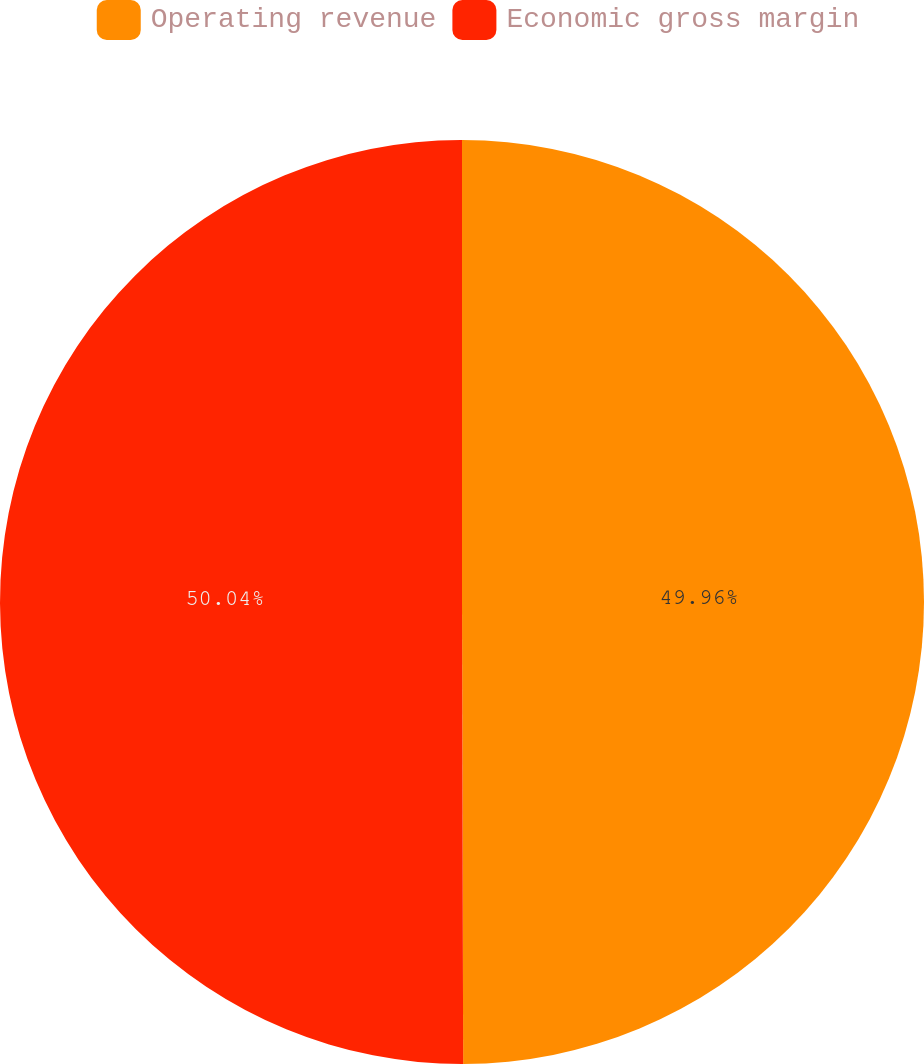Convert chart. <chart><loc_0><loc_0><loc_500><loc_500><pie_chart><fcel>Operating revenue<fcel>Economic gross margin<nl><fcel>49.96%<fcel>50.04%<nl></chart> 